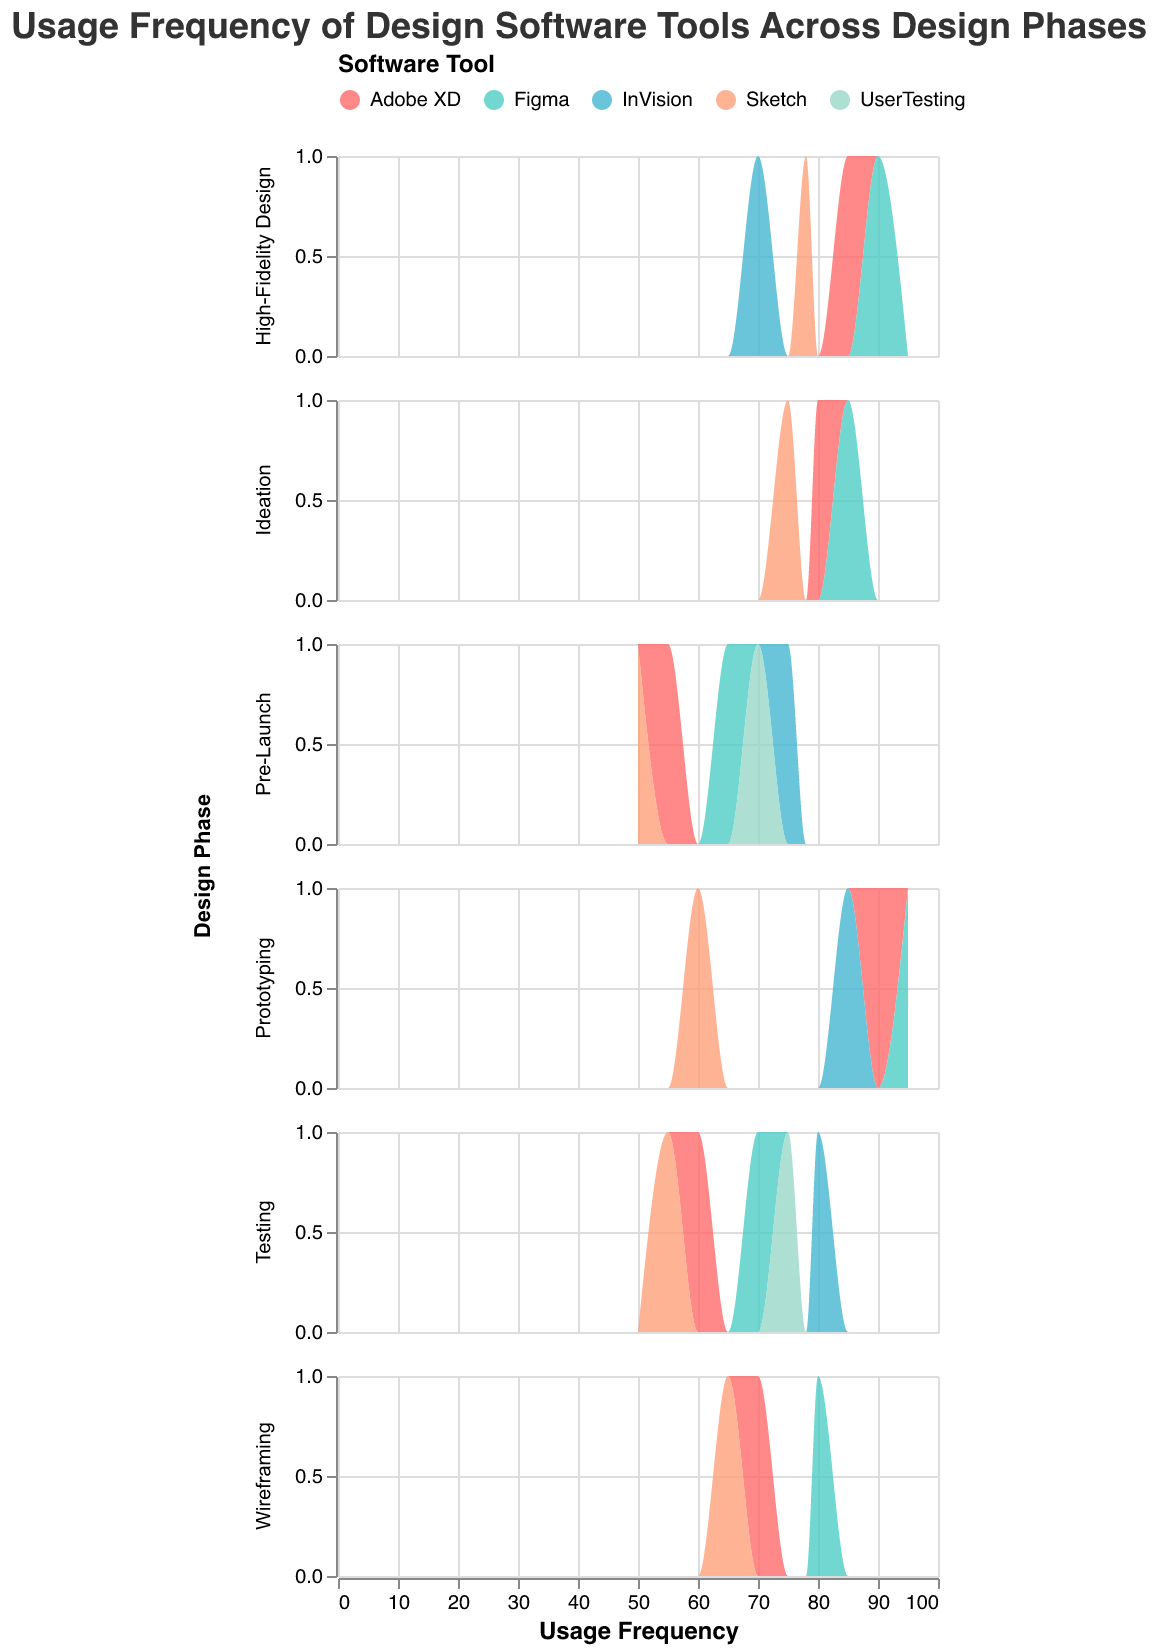What is the title of the figure? The title of the figure can be found at the top of the plot. It reads, "Usage Frequency of Design Software Tools Across Design Phases."
Answer: Usage Frequency of Design Software Tools Across Design Phases How many software tools are represented in the figure? By looking at the legend at the top of the plot, you can see that there are five software tools represented: Adobe XD, Sketch, Figma, InVision, and UserTesting.
Answer: 5 Which design phase shows the highest usage frequency for Figma? The highest usage frequency for Figma can be determined by finding the phase where Figma reaches its peak value on the x-axis. It is in the Prototyping phase, where Figma has a usage frequency of 95.
Answer: Prototyping In the Testing phase, which software tool has the highest usage frequency? By examining the Testing row, you can see that InVision has the highest peak on the x-axis with a usage frequency of 80.
Answer: InVision Compare the usage frequency of Adobe XD and Sketch during the Ideation phase. Which one is used more frequently? In the Ideation phase, Adobe XD has a usage frequency of 80 while Sketch has a usage frequency of 75. Therefore, Adobe XD is used more frequently than Sketch in this phase.
Answer: Adobe XD Which software tool shows a consistent high usage frequency across all design phases? To find this, observe the peaks of each software tool across all phases. Figma consistently shows high usage frequencies in all phases, with values mostly around or above 70.
Answer: Figma What is the range of usage frequencies for UserTesting? UserTesting appears only in the Testing and Pre-Launch phases. In those phases, its usage frequencies are 75 and 70, respectively. So the range is from 70 to 75.
Answer: 70 to 75 Which phase has the lowest usage frequency for Sketch? By examining the lowest peak of Sketch across all phases, you can see that the Pre-Launch phase has the lowest usage frequency of 50.
Answer: Pre-Launch How does the usage frequency of InVision change from the Prototyping phase to the Pre-Launch phase? InVision has a usage frequency of 85 in the Prototyping phase and 75 in the Pre-Launch phase. This shows a decrease of 10 units in usage frequency.
Answer: Decreases by 10 units What is the difference in usage frequency of Adobe XD between the Wireframing phase and the Prototyping phase? Adobe XD has a usage frequency of 70 in the Wireframing phase and 90 in the Prototyping phase. The difference is 90 - 70 = 20 units.
Answer: 20 units 